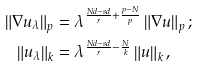<formula> <loc_0><loc_0><loc_500><loc_500>\left \| \nabla u _ { \lambda } \right \| _ { p } & = \lambda ^ { \frac { N d - s d } { r } + \frac { p - N } { p } } \left \| \nabla u \right \| _ { p } ; \\ \left \| u _ { \lambda } \right \| _ { k } & = \lambda ^ { \frac { N d - s d } { r } - \frac { N } { k } } \left \| u \right \| _ { k } ,</formula> 